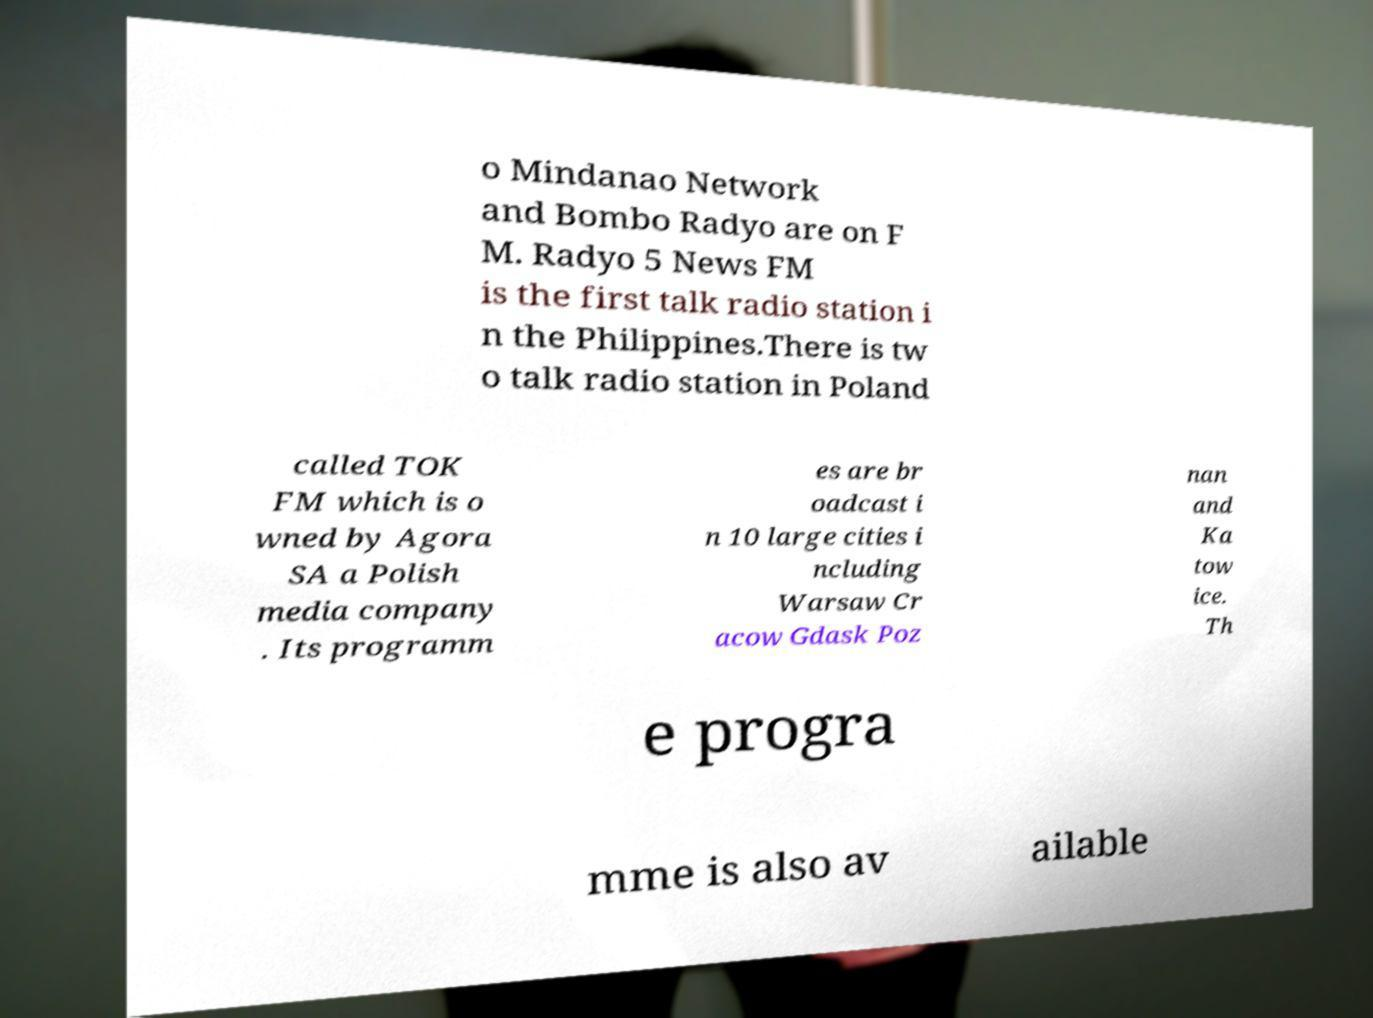What messages or text are displayed in this image? I need them in a readable, typed format. o Mindanao Network and Bombo Radyo are on F M. Radyo 5 News FM is the first talk radio station i n the Philippines.There is tw o talk radio station in Poland called TOK FM which is o wned by Agora SA a Polish media company . Its programm es are br oadcast i n 10 large cities i ncluding Warsaw Cr acow Gdask Poz nan and Ka tow ice. Th e progra mme is also av ailable 